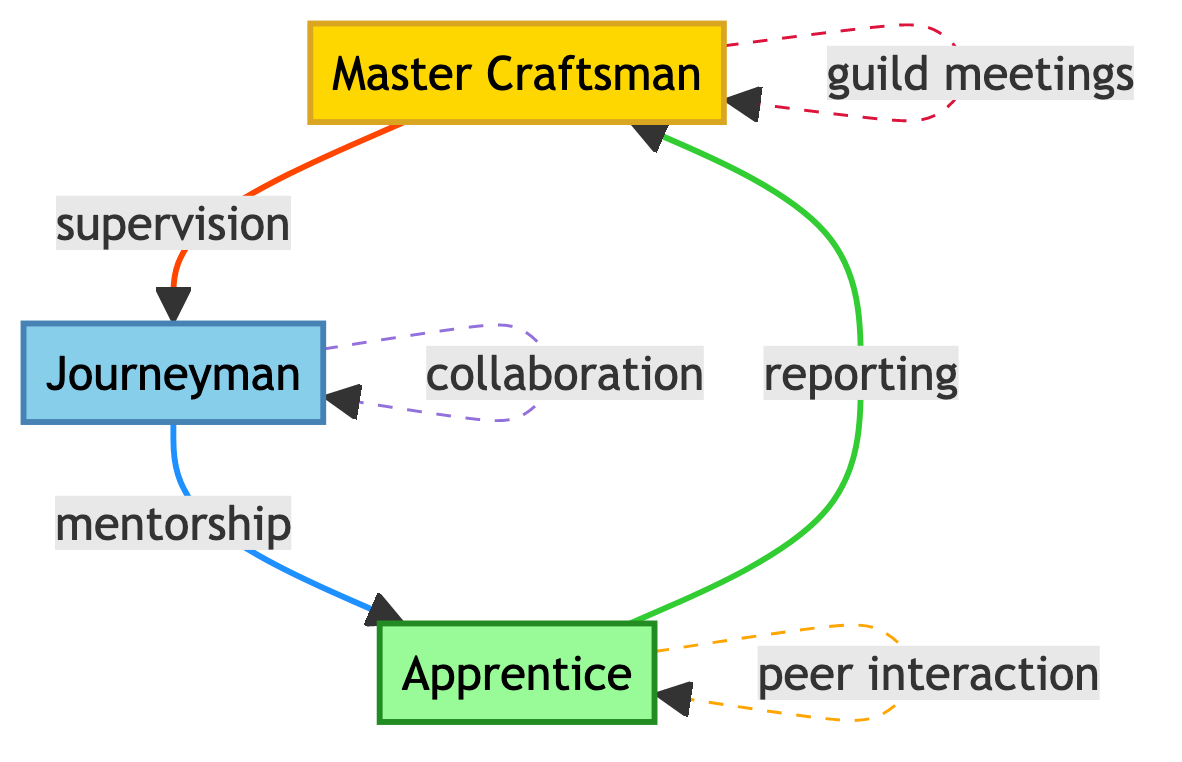What is the highest role in the guild? The diagram indicates that the "Master Craftsman" has the highest role, as he is described as the lead with the most experience.
Answer: Master Craftsman How many nodes are there in the diagram? By counting the distinct roles in the nodes section of the diagram, three roles are present: Master Craftsman, Journeyman, and Apprentice.
Answer: 3 What type of interaction occurs from Journeyman to Apprentice? The diagram specifies that the interaction between a Journeyman and an Apprentice is labeled as "mentorship," indicating the Journeyman’s role in guiding the Apprentice.
Answer: mentorship Who do apprentices report their progress to? According to the diagram, apprentices report their progress to the Master Craftsman, which is specified in the edge labeled "reporting".
Answer: Master Craftsman What is the nature of interactions between Apprentices? The diagram shows that apprentices engage in "peer interaction," which allows them to learn from each other, captured by the interaction labeled as "peer interaction."
Answer: peer interaction What is the total number of edges connecting the roles in the diagram? The diagram outlines five specific interactions or edges connecting the roles, detailing how they relate to each other.
Answer: 5 Which two roles have a collaboration interaction? Referring to the diagram, the "Journeyman" is identified as having a "collaboration" interaction with other Journeymen, indicating that they work together.
Answer: Journeyman What is the purpose of guild meetings based on the diagram? The diagram reveals that guild meetings are held by Masters to discuss guild affairs, as indicated by the edge labeled "guild meetings."
Answer: discuss guild affairs What do Masters do in relation to Journeymen? The interaction indicated in the diagram is "supervision," which specifies that Masters oversee Journeymen and provide them with tasks.
Answer: supervision 